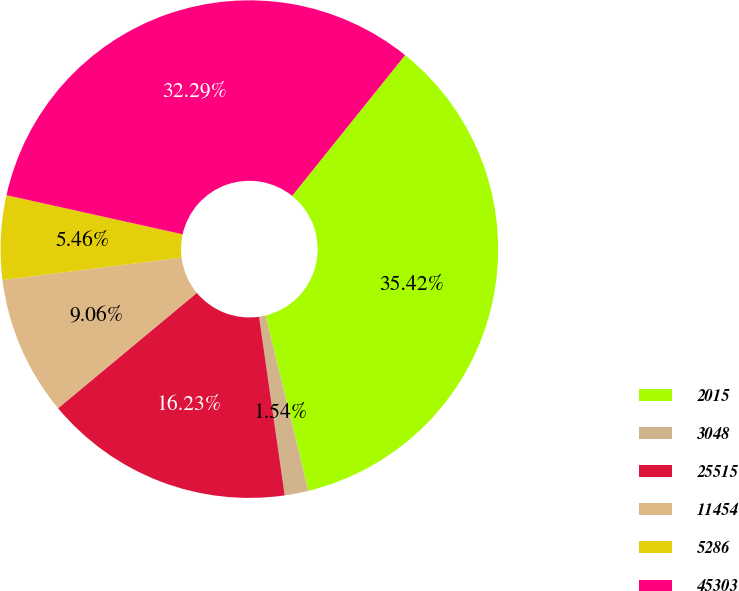Convert chart. <chart><loc_0><loc_0><loc_500><loc_500><pie_chart><fcel>2015<fcel>3048<fcel>25515<fcel>11454<fcel>5286<fcel>45303<nl><fcel>35.42%<fcel>1.54%<fcel>16.23%<fcel>9.06%<fcel>5.46%<fcel>32.29%<nl></chart> 